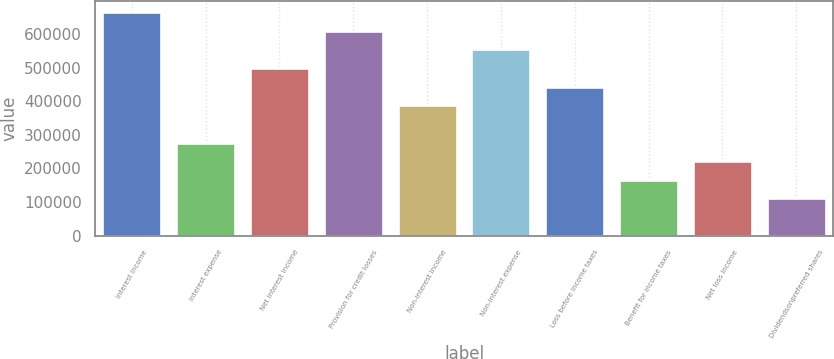Convert chart. <chart><loc_0><loc_0><loc_500><loc_500><bar_chart><fcel>Interest income<fcel>Interest expense<fcel>Net interest income<fcel>Provision for credit losses<fcel>Non-interest income<fcel>Non-interest expense<fcel>Loss before income taxes<fcel>Benefit for income taxes<fcel>Net loss income<fcel>Dividendsonpreferred shares<nl><fcel>664615<fcel>276923<fcel>498461<fcel>609231<fcel>387692<fcel>553846<fcel>443077<fcel>166154<fcel>221539<fcel>110769<nl></chart> 